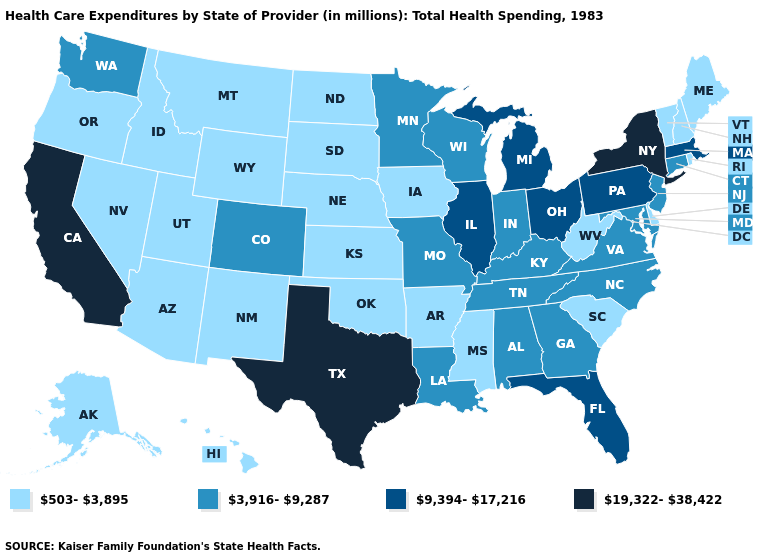What is the value of Tennessee?
Be succinct. 3,916-9,287. What is the value of Nevada?
Be succinct. 503-3,895. Which states hav the highest value in the MidWest?
Answer briefly. Illinois, Michigan, Ohio. What is the value of Indiana?
Short answer required. 3,916-9,287. What is the value of Missouri?
Quick response, please. 3,916-9,287. What is the highest value in the West ?
Answer briefly. 19,322-38,422. Name the states that have a value in the range 3,916-9,287?
Be succinct. Alabama, Colorado, Connecticut, Georgia, Indiana, Kentucky, Louisiana, Maryland, Minnesota, Missouri, New Jersey, North Carolina, Tennessee, Virginia, Washington, Wisconsin. Name the states that have a value in the range 19,322-38,422?
Concise answer only. California, New York, Texas. What is the value of Louisiana?
Be succinct. 3,916-9,287. What is the lowest value in the USA?
Quick response, please. 503-3,895. What is the value of Montana?
Give a very brief answer. 503-3,895. Name the states that have a value in the range 9,394-17,216?
Quick response, please. Florida, Illinois, Massachusetts, Michigan, Ohio, Pennsylvania. What is the highest value in the USA?
Write a very short answer. 19,322-38,422. Among the states that border Georgia , does North Carolina have the highest value?
Quick response, please. No. Name the states that have a value in the range 3,916-9,287?
Write a very short answer. Alabama, Colorado, Connecticut, Georgia, Indiana, Kentucky, Louisiana, Maryland, Minnesota, Missouri, New Jersey, North Carolina, Tennessee, Virginia, Washington, Wisconsin. 